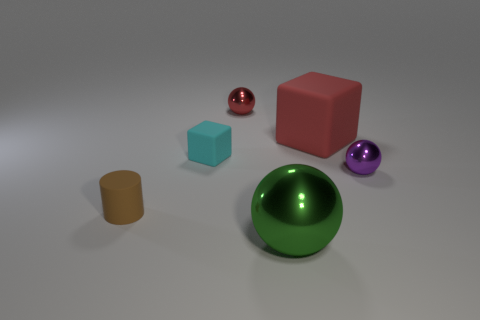Are there an equal number of green metal spheres that are to the left of the tiny brown rubber cylinder and purple objects behind the green shiny object?
Provide a short and direct response. No. The tiny shiny object behind the large object that is behind the brown rubber cylinder is what shape?
Give a very brief answer. Sphere. Are there any green shiny objects of the same shape as the small cyan matte object?
Give a very brief answer. No. What number of large brown shiny cylinders are there?
Keep it short and to the point. 0. Are the object in front of the cylinder and the large red thing made of the same material?
Your answer should be compact. No. Are there any cyan rubber things of the same size as the green object?
Provide a short and direct response. No. Is the shape of the big matte object the same as the red thing that is behind the large red block?
Ensure brevity in your answer.  No. There is a cube that is to the left of the metal sphere that is in front of the brown rubber cylinder; are there any small things in front of it?
Provide a succinct answer. Yes. How big is the green metal ball?
Ensure brevity in your answer.  Large. How many other things are the same color as the matte cylinder?
Provide a short and direct response. 0. 